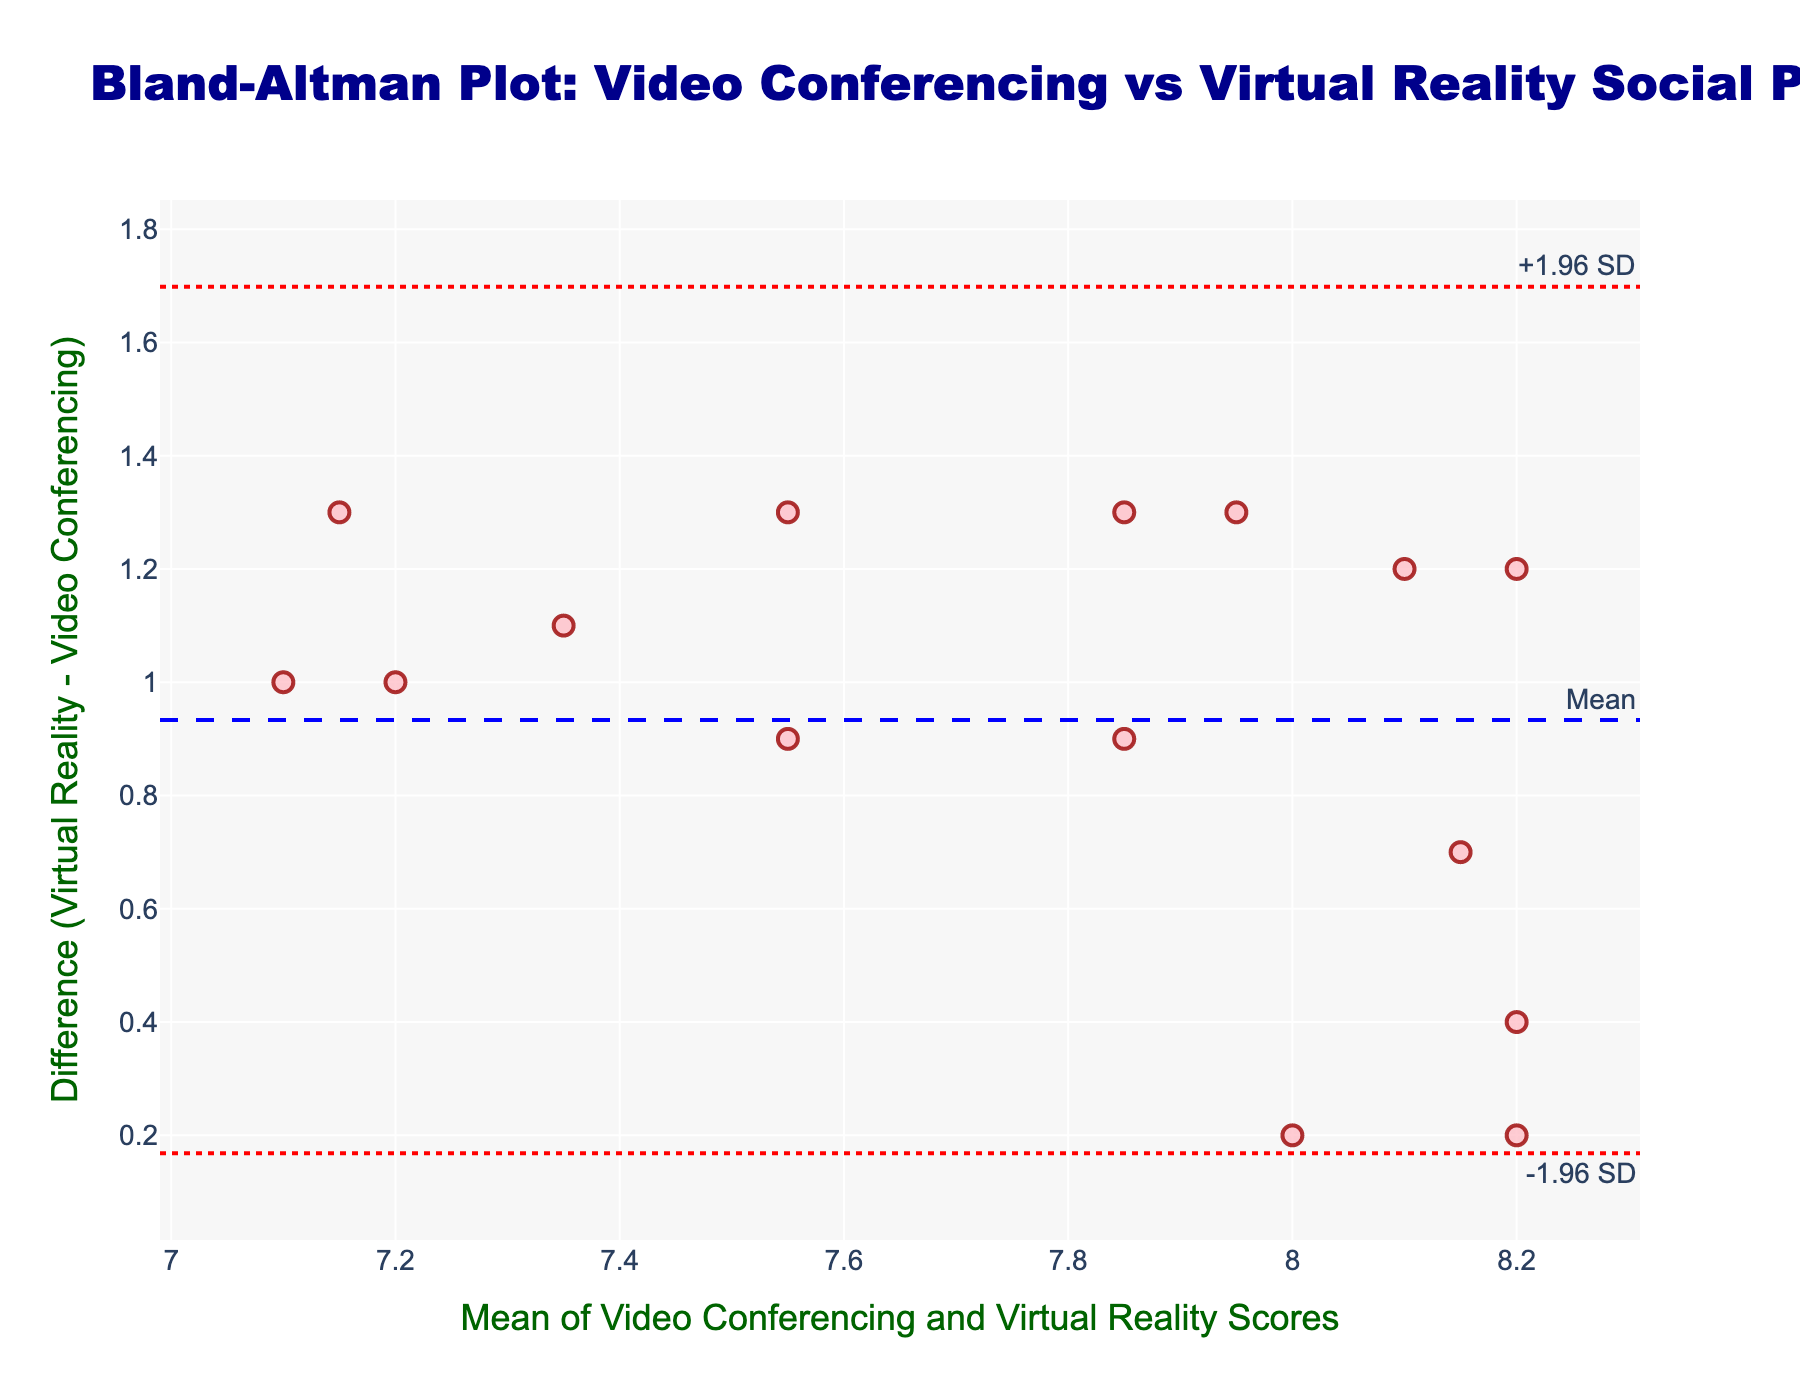How many data points are displayed in the Bland-Altman plot? There are 15 participants listed; thus, there are 15 data points on the plot, each representing one participant's mean score and difference.
Answer: 15 What is the mean difference between the Virtual Reality and Video Conferencing scores? The mean difference is plotted as a horizontal blue dashed line. From the figure, this mean difference is annotated as the mean difference on the plot.
Answer: Mean difference What are the upper and lower limits of agreement? The upper and lower limits of agreement are represented by the two red dotted lines annotated with "+1.96 SD" and "-1.96 SD." These lines indicate the standard deviation limits from the mean difference.
Answer: Upper limit and lower limit of agreement What is the range of the mean (x-axis) values in this plot? The x-axis shows the means of the scores from both conditions. The minimum and maximum mean values on the x-axis can be determined by examining the range covered by the data points along the x-axis.
Answer: Range of mean values Which participant has the maximum difference (Virtual Reality - Video Conferencing)? The participant with the maximum difference will be the one represented by the highest (topmost) data point on the y-axis.
Answer: Participant with maximum difference Which participant has the closest Virtual Reality and Video Conferencing scores? The participant with the closest scores will have a difference closest to zero, marked by data points closest to the y=0 horizontal line.
Answer: Participant with closest scores Is there any participant whose perceived social presence is rated higher in Video Conferencing than in Virtual Reality? If a data point is below the zero line on the y-axis, it indicates that the Video Conferencing score is higher than the Virtual Reality score for that participant.
Answer: Any data point below zero line What can you infer if most data points lie within the limits of agreement? If most data points are within the limits of agreement, it suggests that there is good agreement between Video Conferencing and Virtual Reality scores, and the differences are not significant.
Answer: Good agreement What does a wider spread along the y-axis imply about the agreement between the two scores? A wider spread along the y-axis means higher variability in the differences between the two scores, indicating less agreement between Video Conferencing and Virtual Reality scores.
Answer: Less agreement Is the difference between the Virtual Reality and Video Conferencing scores generally positive or negative? Observing the vertical placement of the majority of data points relative to the y=0 line will indicate if differences are mostly positive (above line) or negative (below line).
Answer: Generally positive 